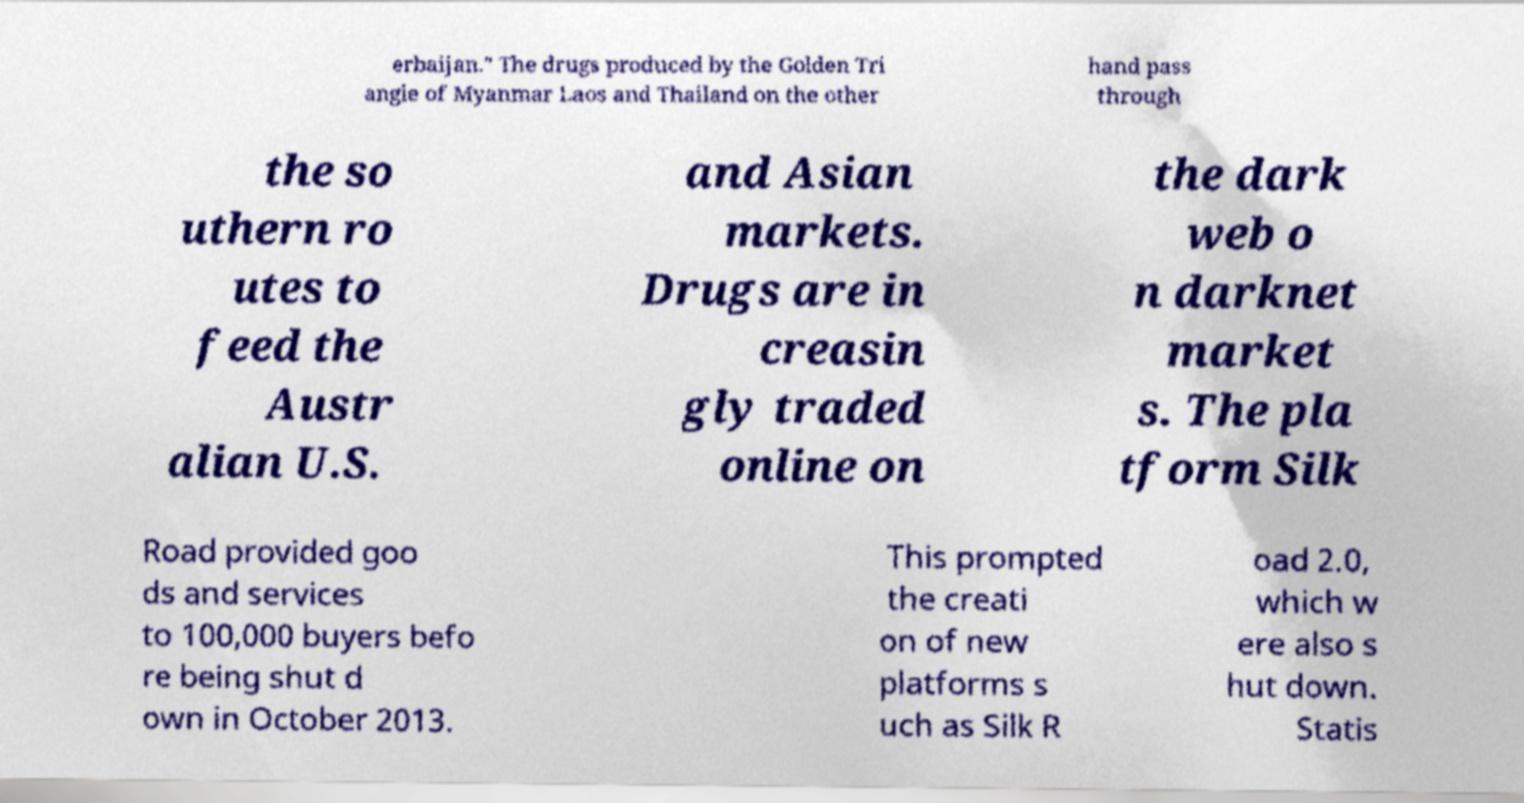Can you accurately transcribe the text from the provided image for me? erbaijan." The drugs produced by the Golden Tri angle of Myanmar Laos and Thailand on the other hand pass through the so uthern ro utes to feed the Austr alian U.S. and Asian markets. Drugs are in creasin gly traded online on the dark web o n darknet market s. The pla tform Silk Road provided goo ds and services to 100,000 buyers befo re being shut d own in October 2013. This prompted the creati on of new platforms s uch as Silk R oad 2.0, which w ere also s hut down. Statis 